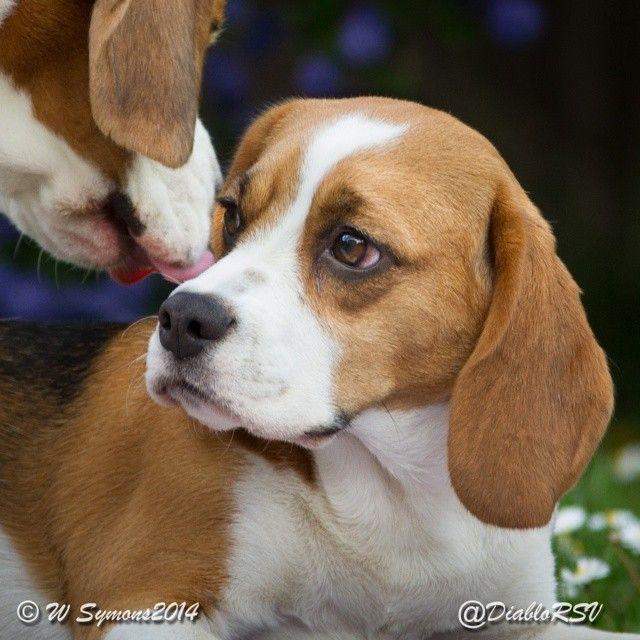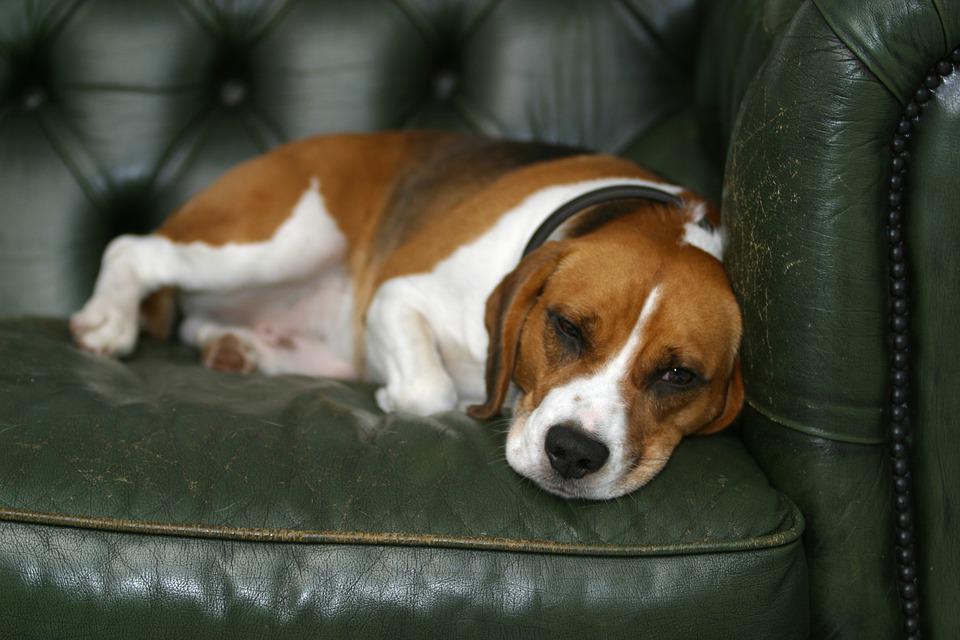The first image is the image on the left, the second image is the image on the right. For the images displayed, is the sentence "There are at most two dogs." factually correct? Answer yes or no. No. 